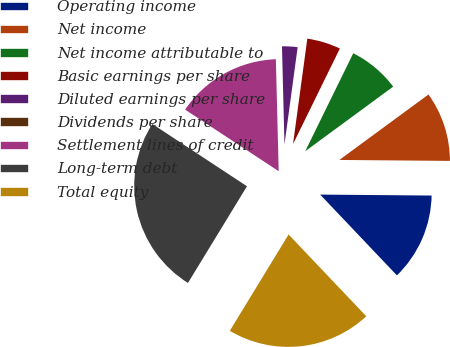<chart> <loc_0><loc_0><loc_500><loc_500><pie_chart><fcel>Operating income<fcel>Net income<fcel>Net income attributable to<fcel>Basic earnings per share<fcel>Diluted earnings per share<fcel>Dividends per share<fcel>Settlement lines of credit<fcel>Long-term debt<fcel>Total equity<nl><fcel>12.77%<fcel>10.22%<fcel>7.66%<fcel>5.11%<fcel>2.55%<fcel>0.0%<fcel>15.33%<fcel>25.54%<fcel>20.81%<nl></chart> 